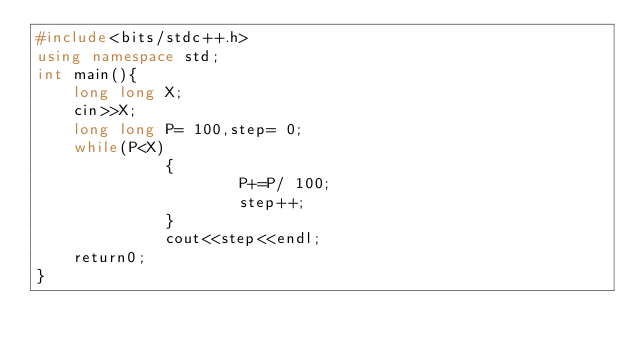Convert code to text. <code><loc_0><loc_0><loc_500><loc_500><_C++_>#include<bits/stdc++.h>
using namespace std;
int main(){
    long long X;
    cin>>X;
    long long P= 100,step= 0;
    while(P<X)
              {
                      P+=P/ 100;
                      step++;
              }
              cout<<step<<endl;
    return0;
}</code> 